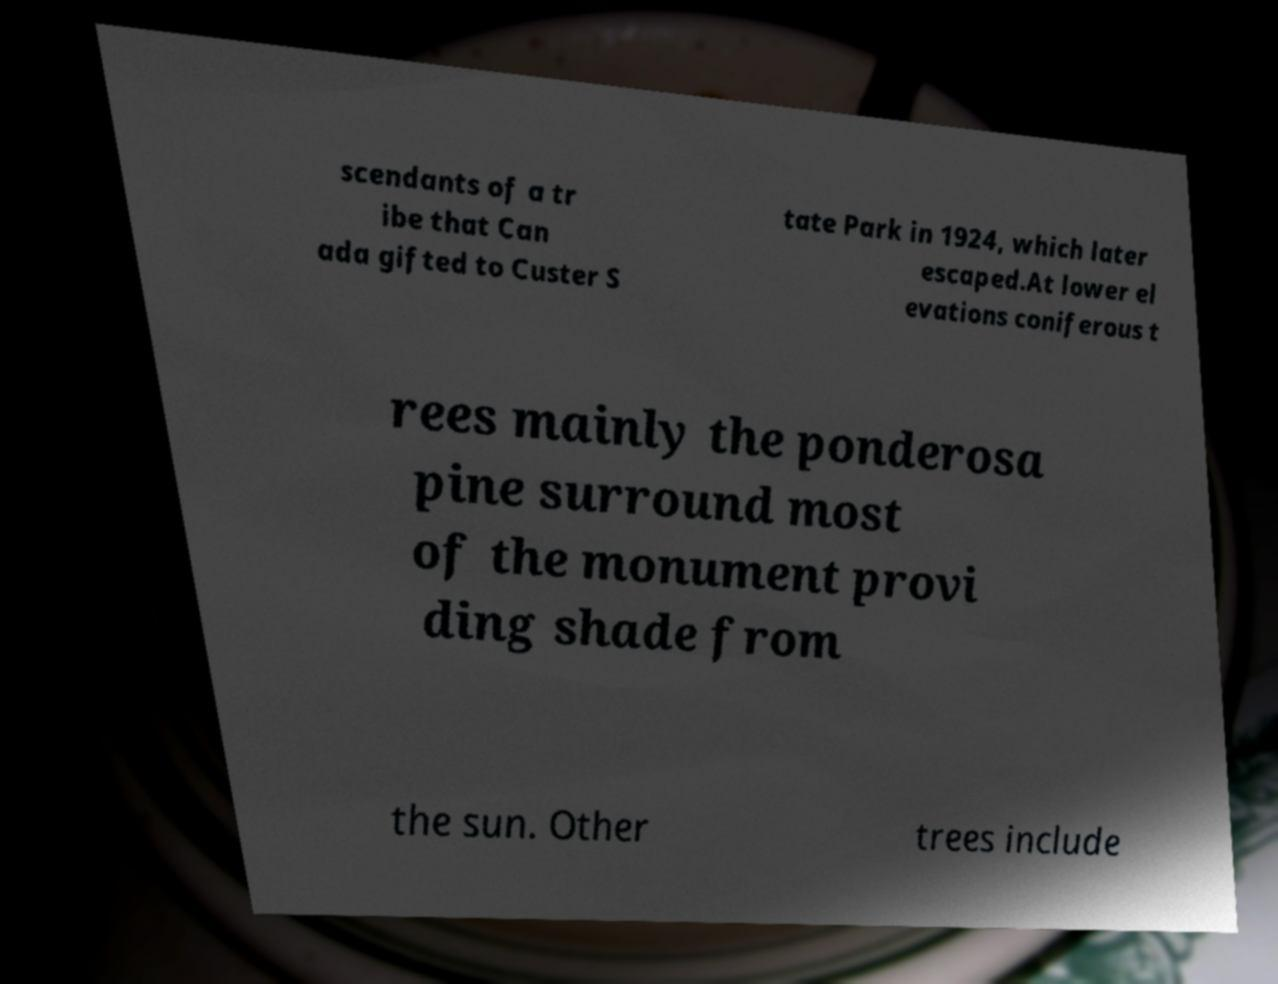Could you extract and type out the text from this image? scendants of a tr ibe that Can ada gifted to Custer S tate Park in 1924, which later escaped.At lower el evations coniferous t rees mainly the ponderosa pine surround most of the monument provi ding shade from the sun. Other trees include 